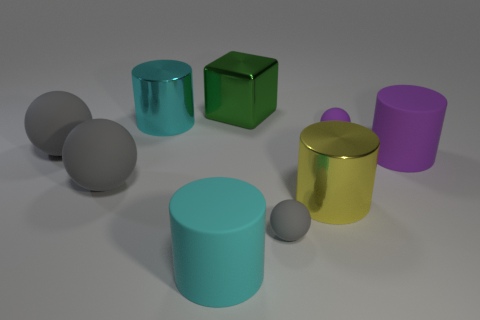Subtract all brown blocks. How many gray balls are left? 3 Subtract all gray matte balls. How many balls are left? 1 Subtract 2 balls. How many balls are left? 2 Add 1 big rubber cylinders. How many objects exist? 10 Subtract all gray cylinders. Subtract all red blocks. How many cylinders are left? 4 Subtract all cylinders. How many objects are left? 5 Subtract 0 yellow balls. How many objects are left? 9 Subtract all large matte cylinders. Subtract all large cyan matte cylinders. How many objects are left? 6 Add 9 small purple rubber things. How many small purple rubber things are left? 10 Add 5 large cylinders. How many large cylinders exist? 9 